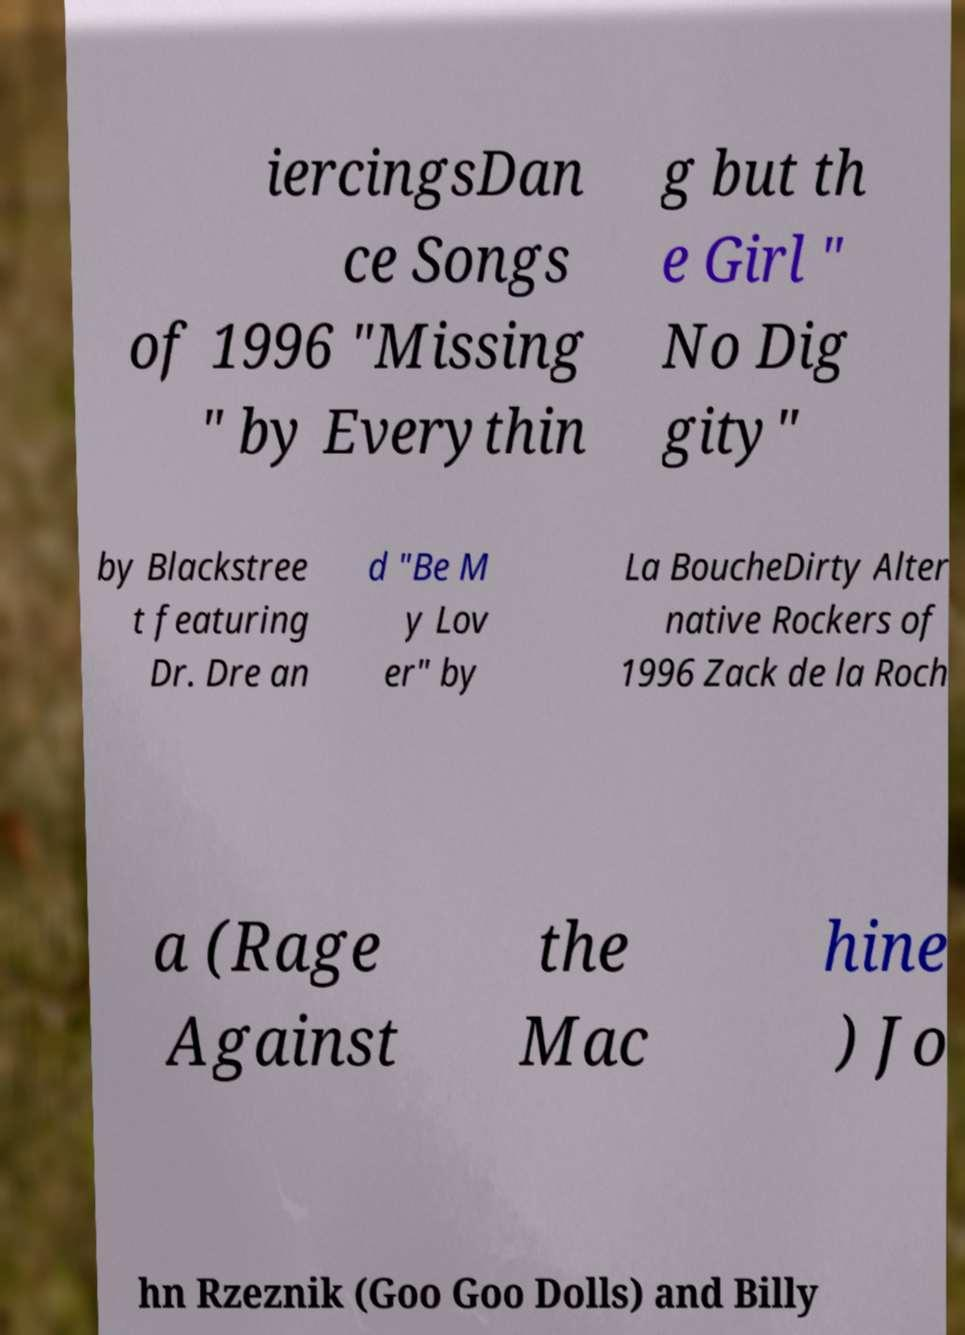Please identify and transcribe the text found in this image. iercingsDan ce Songs of 1996 "Missing " by Everythin g but th e Girl " No Dig gity" by Blackstree t featuring Dr. Dre an d "Be M y Lov er" by La BoucheDirty Alter native Rockers of 1996 Zack de la Roch a (Rage Against the Mac hine ) Jo hn Rzeznik (Goo Goo Dolls) and Billy 